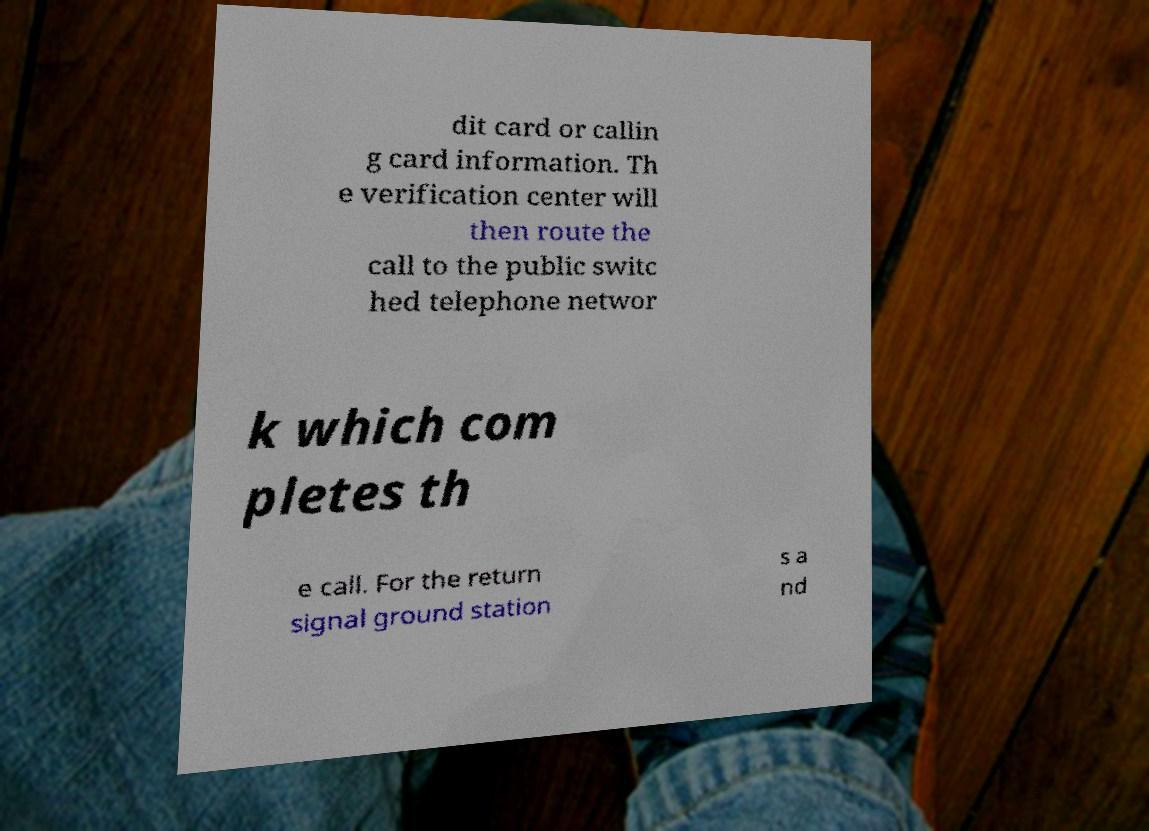Please identify and transcribe the text found in this image. dit card or callin g card information. Th e verification center will then route the call to the public switc hed telephone networ k which com pletes th e call. For the return signal ground station s a nd 